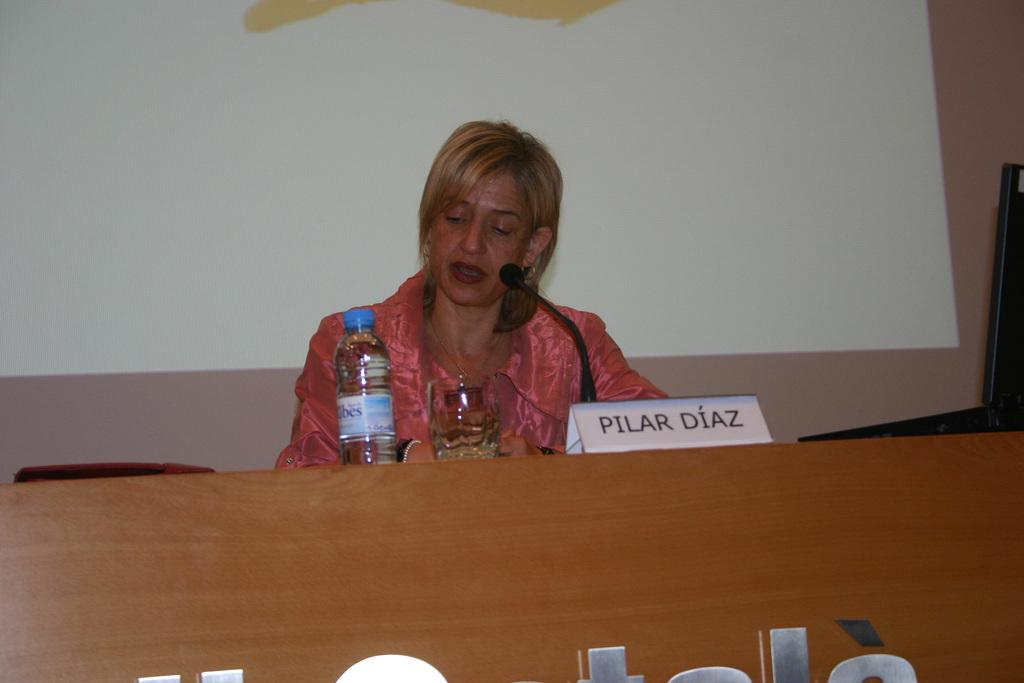What is the woman in the image doing? The woman is sitting in the image. What object is in front of the woman? There is a microphone in front of the woman. What items related to drinking can be seen in the image? There is a bottle and a glass in the image. What can be seen in the background of the image? There is a wall visible in the background of the image. What type of brass instrument is the woman playing in the image? There is no brass instrument present in the image; the woman is sitting with a microphone in front of her. What color is the woman's hair in the image? The provided facts do not mention the color of the woman's hair, so it cannot be determined from the image. 